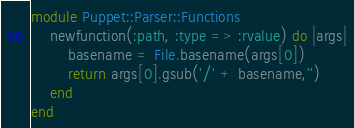<code> <loc_0><loc_0><loc_500><loc_500><_Ruby_>module Puppet::Parser::Functions
	newfunction(:path, :type => :rvalue) do |args|
		basename = File.basename(args[0])
		return args[0].gsub('/' + basename,'')
	end
end
</code> 